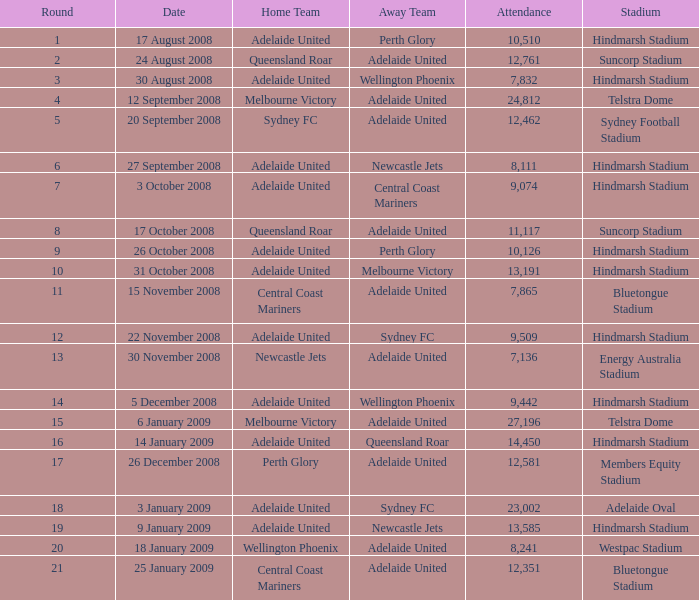On october 26, 2008, during which round were there 11,117 attendees at the game? 9.0. 